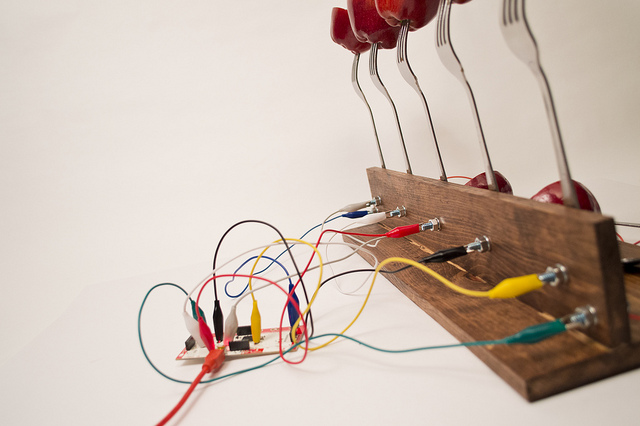<image>What is this machine going to do? It is unknown what this machine is going to do. It could potentially create electricity, burn apples, or even throw apples. What is this machine going to do? It is ambiguous what this machine is going to do. It can be seen blowing up, throwing apples, burning apples, creating electricity, or shocking apples. 